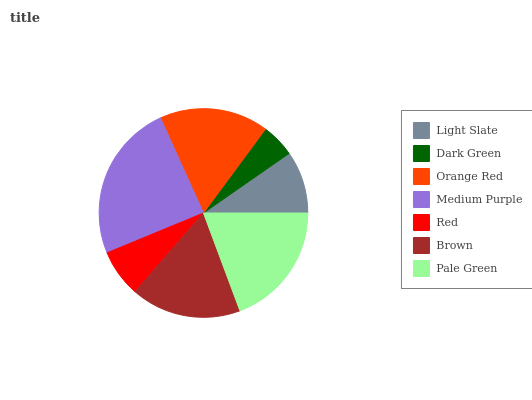Is Dark Green the minimum?
Answer yes or no. Yes. Is Medium Purple the maximum?
Answer yes or no. Yes. Is Orange Red the minimum?
Answer yes or no. No. Is Orange Red the maximum?
Answer yes or no. No. Is Orange Red greater than Dark Green?
Answer yes or no. Yes. Is Dark Green less than Orange Red?
Answer yes or no. Yes. Is Dark Green greater than Orange Red?
Answer yes or no. No. Is Orange Red less than Dark Green?
Answer yes or no. No. Is Orange Red the high median?
Answer yes or no. Yes. Is Orange Red the low median?
Answer yes or no. Yes. Is Dark Green the high median?
Answer yes or no. No. Is Red the low median?
Answer yes or no. No. 